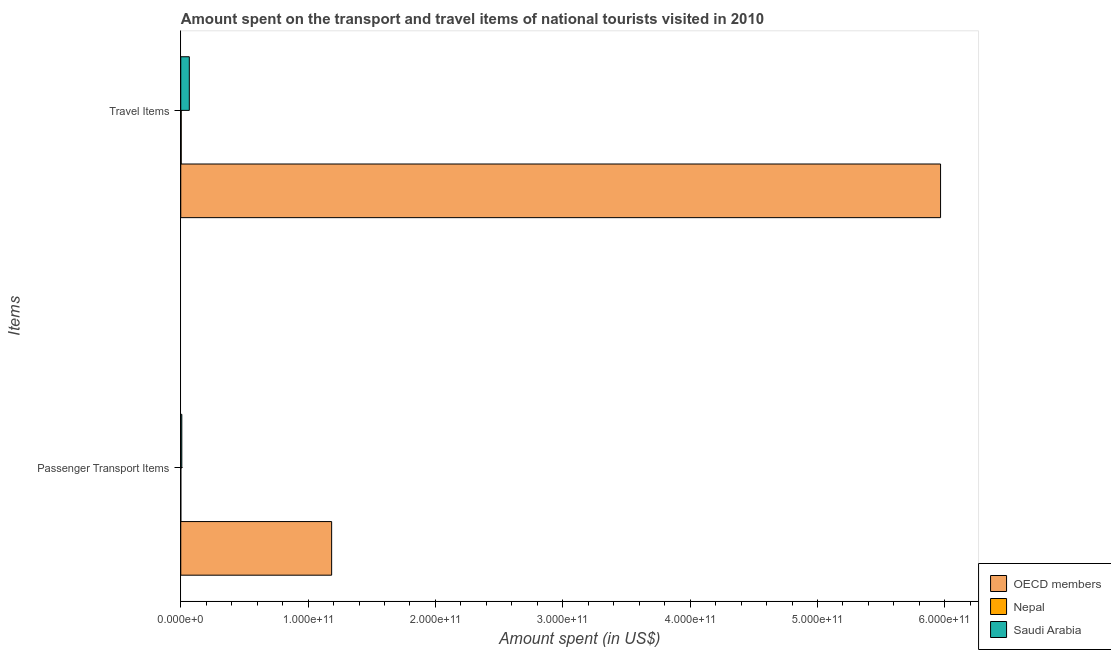How many different coloured bars are there?
Ensure brevity in your answer.  3. How many groups of bars are there?
Keep it short and to the point. 2. Are the number of bars per tick equal to the number of legend labels?
Keep it short and to the point. Yes. How many bars are there on the 1st tick from the top?
Offer a very short reply. 3. What is the label of the 2nd group of bars from the top?
Keep it short and to the point. Passenger Transport Items. What is the amount spent in travel items in OECD members?
Offer a very short reply. 5.97e+11. Across all countries, what is the maximum amount spent on passenger transport items?
Provide a short and direct response. 1.18e+11. Across all countries, what is the minimum amount spent on passenger transport items?
Offer a very short reply. 3.40e+07. In which country was the amount spent in travel items maximum?
Ensure brevity in your answer.  OECD members. In which country was the amount spent in travel items minimum?
Your answer should be very brief. Nepal. What is the total amount spent in travel items in the graph?
Give a very brief answer. 6.04e+11. What is the difference between the amount spent in travel items in OECD members and that in Saudi Arabia?
Provide a short and direct response. 5.90e+11. What is the difference between the amount spent on passenger transport items in Saudi Arabia and the amount spent in travel items in OECD members?
Your answer should be compact. -5.96e+11. What is the average amount spent on passenger transport items per country?
Give a very brief answer. 3.98e+1. What is the difference between the amount spent on passenger transport items and amount spent in travel items in Nepal?
Provide a short and direct response. -3.10e+08. What is the ratio of the amount spent on passenger transport items in OECD members to that in Nepal?
Offer a very short reply. 3484.62. Is the amount spent on passenger transport items in Nepal less than that in OECD members?
Provide a short and direct response. Yes. What does the 1st bar from the top in Passenger Transport Items represents?
Provide a succinct answer. Saudi Arabia. Are all the bars in the graph horizontal?
Your answer should be very brief. Yes. What is the difference between two consecutive major ticks on the X-axis?
Offer a terse response. 1.00e+11. Does the graph contain grids?
Offer a terse response. No. Where does the legend appear in the graph?
Provide a short and direct response. Bottom right. What is the title of the graph?
Provide a succinct answer. Amount spent on the transport and travel items of national tourists visited in 2010. Does "Kenya" appear as one of the legend labels in the graph?
Provide a succinct answer. No. What is the label or title of the X-axis?
Ensure brevity in your answer.  Amount spent (in US$). What is the label or title of the Y-axis?
Your answer should be very brief. Items. What is the Amount spent (in US$) in OECD members in Passenger Transport Items?
Give a very brief answer. 1.18e+11. What is the Amount spent (in US$) of Nepal in Passenger Transport Items?
Your response must be concise. 3.40e+07. What is the Amount spent (in US$) in Saudi Arabia in Passenger Transport Items?
Your answer should be compact. 8.24e+08. What is the Amount spent (in US$) in OECD members in Travel Items?
Offer a very short reply. 5.97e+11. What is the Amount spent (in US$) in Nepal in Travel Items?
Make the answer very short. 3.44e+08. What is the Amount spent (in US$) in Saudi Arabia in Travel Items?
Your response must be concise. 6.71e+09. Across all Items, what is the maximum Amount spent (in US$) in OECD members?
Provide a succinct answer. 5.97e+11. Across all Items, what is the maximum Amount spent (in US$) of Nepal?
Provide a short and direct response. 3.44e+08. Across all Items, what is the maximum Amount spent (in US$) of Saudi Arabia?
Your answer should be compact. 6.71e+09. Across all Items, what is the minimum Amount spent (in US$) in OECD members?
Your answer should be compact. 1.18e+11. Across all Items, what is the minimum Amount spent (in US$) in Nepal?
Provide a short and direct response. 3.40e+07. Across all Items, what is the minimum Amount spent (in US$) of Saudi Arabia?
Your response must be concise. 8.24e+08. What is the total Amount spent (in US$) of OECD members in the graph?
Ensure brevity in your answer.  7.15e+11. What is the total Amount spent (in US$) in Nepal in the graph?
Your answer should be very brief. 3.78e+08. What is the total Amount spent (in US$) of Saudi Arabia in the graph?
Keep it short and to the point. 7.54e+09. What is the difference between the Amount spent (in US$) of OECD members in Passenger Transport Items and that in Travel Items?
Provide a short and direct response. -4.78e+11. What is the difference between the Amount spent (in US$) in Nepal in Passenger Transport Items and that in Travel Items?
Your answer should be compact. -3.10e+08. What is the difference between the Amount spent (in US$) in Saudi Arabia in Passenger Transport Items and that in Travel Items?
Keep it short and to the point. -5.89e+09. What is the difference between the Amount spent (in US$) of OECD members in Passenger Transport Items and the Amount spent (in US$) of Nepal in Travel Items?
Your answer should be compact. 1.18e+11. What is the difference between the Amount spent (in US$) in OECD members in Passenger Transport Items and the Amount spent (in US$) in Saudi Arabia in Travel Items?
Ensure brevity in your answer.  1.12e+11. What is the difference between the Amount spent (in US$) in Nepal in Passenger Transport Items and the Amount spent (in US$) in Saudi Arabia in Travel Items?
Ensure brevity in your answer.  -6.68e+09. What is the average Amount spent (in US$) in OECD members per Items?
Offer a terse response. 3.58e+11. What is the average Amount spent (in US$) of Nepal per Items?
Your answer should be very brief. 1.89e+08. What is the average Amount spent (in US$) of Saudi Arabia per Items?
Provide a succinct answer. 3.77e+09. What is the difference between the Amount spent (in US$) in OECD members and Amount spent (in US$) in Nepal in Passenger Transport Items?
Your response must be concise. 1.18e+11. What is the difference between the Amount spent (in US$) of OECD members and Amount spent (in US$) of Saudi Arabia in Passenger Transport Items?
Ensure brevity in your answer.  1.18e+11. What is the difference between the Amount spent (in US$) in Nepal and Amount spent (in US$) in Saudi Arabia in Passenger Transport Items?
Offer a terse response. -7.90e+08. What is the difference between the Amount spent (in US$) of OECD members and Amount spent (in US$) of Nepal in Travel Items?
Offer a terse response. 5.96e+11. What is the difference between the Amount spent (in US$) in OECD members and Amount spent (in US$) in Saudi Arabia in Travel Items?
Ensure brevity in your answer.  5.90e+11. What is the difference between the Amount spent (in US$) of Nepal and Amount spent (in US$) of Saudi Arabia in Travel Items?
Offer a terse response. -6.37e+09. What is the ratio of the Amount spent (in US$) of OECD members in Passenger Transport Items to that in Travel Items?
Provide a short and direct response. 0.2. What is the ratio of the Amount spent (in US$) in Nepal in Passenger Transport Items to that in Travel Items?
Provide a succinct answer. 0.1. What is the ratio of the Amount spent (in US$) of Saudi Arabia in Passenger Transport Items to that in Travel Items?
Keep it short and to the point. 0.12. What is the difference between the highest and the second highest Amount spent (in US$) of OECD members?
Offer a terse response. 4.78e+11. What is the difference between the highest and the second highest Amount spent (in US$) of Nepal?
Offer a very short reply. 3.10e+08. What is the difference between the highest and the second highest Amount spent (in US$) in Saudi Arabia?
Make the answer very short. 5.89e+09. What is the difference between the highest and the lowest Amount spent (in US$) in OECD members?
Give a very brief answer. 4.78e+11. What is the difference between the highest and the lowest Amount spent (in US$) of Nepal?
Provide a short and direct response. 3.10e+08. What is the difference between the highest and the lowest Amount spent (in US$) in Saudi Arabia?
Offer a terse response. 5.89e+09. 